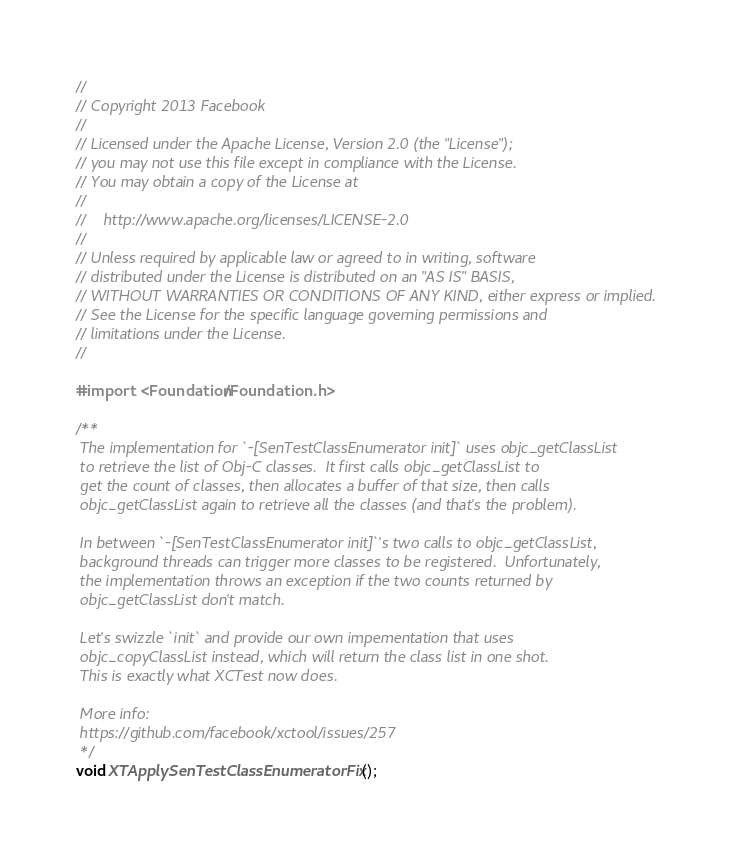Convert code to text. <code><loc_0><loc_0><loc_500><loc_500><_C_>//
// Copyright 2013 Facebook
//
// Licensed under the Apache License, Version 2.0 (the "License");
// you may not use this file except in compliance with the License.
// You may obtain a copy of the License at
//
//    http://www.apache.org/licenses/LICENSE-2.0
//
// Unless required by applicable law or agreed to in writing, software
// distributed under the License is distributed on an "AS IS" BASIS,
// WITHOUT WARRANTIES OR CONDITIONS OF ANY KIND, either express or implied.
// See the License for the specific language governing permissions and
// limitations under the License.
//

#import <Foundation/Foundation.h>

/**
 The implementation for `-[SenTestClassEnumerator init]` uses objc_getClassList
 to retrieve the list of Obj-C classes.  It first calls objc_getClassList to
 get the count of classes, then allocates a buffer of that size, then calls
 objc_getClassList again to retrieve all the classes (and that's the problem).
 
 In between `-[SenTestClassEnumerator init]`'s two calls to objc_getClassList,
 background threads can trigger more classes to be registered.  Unfortunately,
 the implementation throws an exception if the two counts returned by
 objc_getClassList don't match.
 
 Let's swizzle `init` and provide our own impementation that uses
 objc_copyClassList instead, which will return the class list in one shot.
 This is exactly what XCTest now does.

 More info:
 https://github.com/facebook/xctool/issues/257
 */
void XTApplySenTestClassEnumeratorFix();</code> 